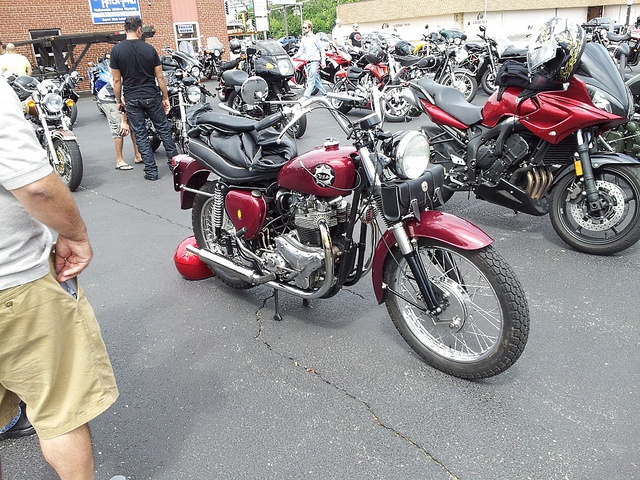Describe the objects in this image and their specific colors. I can see motorcycle in tan, black, darkgray, gray, and lightgray tones, motorcycle in tan, black, gray, darkgray, and lightgray tones, people in tan and white tones, motorcycle in tan, white, darkgray, gray, and black tones, and people in tan, black, and gray tones in this image. 